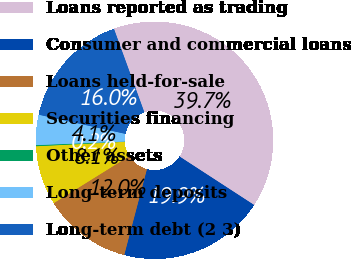Convert chart. <chart><loc_0><loc_0><loc_500><loc_500><pie_chart><fcel>Loans reported as trading<fcel>Consumer and commercial loans<fcel>Loans held-for-sale<fcel>Securities financing<fcel>Other assets<fcel>Long-term deposits<fcel>Long-term debt (2 3)<nl><fcel>39.73%<fcel>19.94%<fcel>12.02%<fcel>8.07%<fcel>0.15%<fcel>4.11%<fcel>15.98%<nl></chart> 